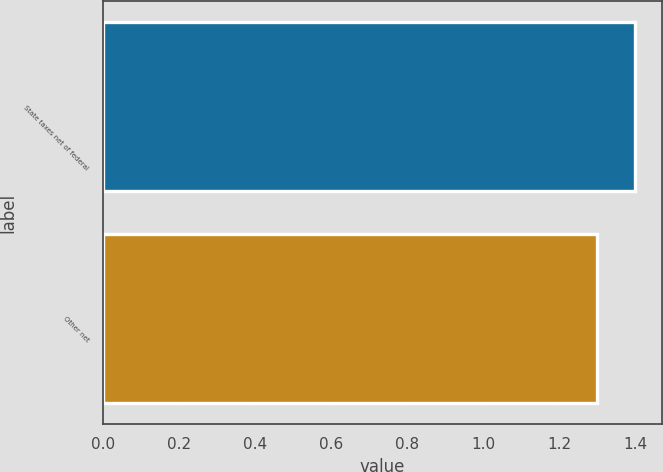<chart> <loc_0><loc_0><loc_500><loc_500><bar_chart><fcel>State taxes net of federal<fcel>Other net<nl><fcel>1.4<fcel>1.3<nl></chart> 